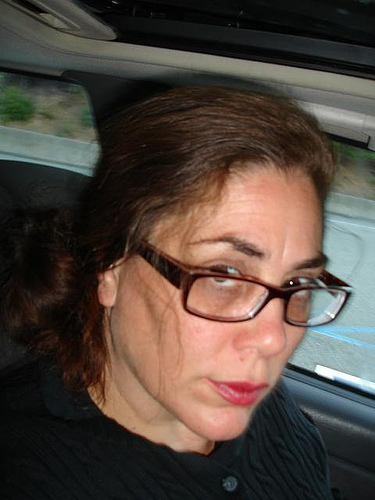<image>
Can you confirm if the eye glass is in front of the woman? Yes. The eye glass is positioned in front of the woman, appearing closer to the camera viewpoint. 